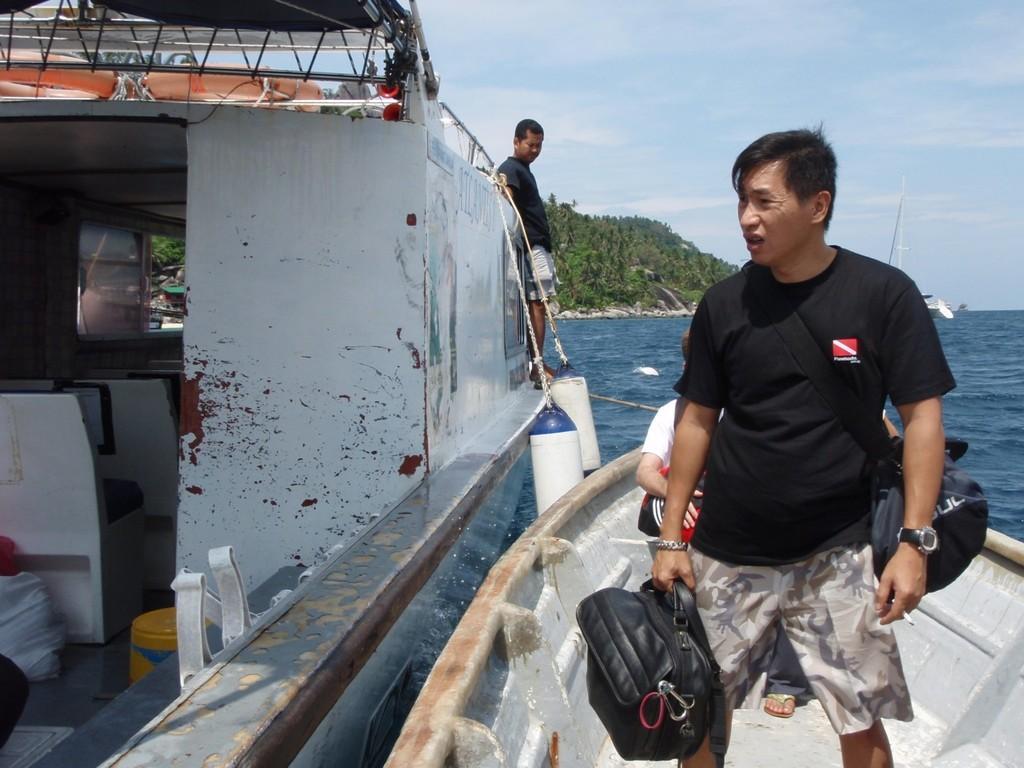Could you give a brief overview of what you see in this image? In this image there one person standing on the right side of this image is wearing a black color t shirt and holding a bag,and there is one more person is sitting in the boat. There is a ship on the left side of this image and there is one person standing on to this ship. There is a sea on the right side of this image and there are some trees in the background. There is a sky on the top of this image. 